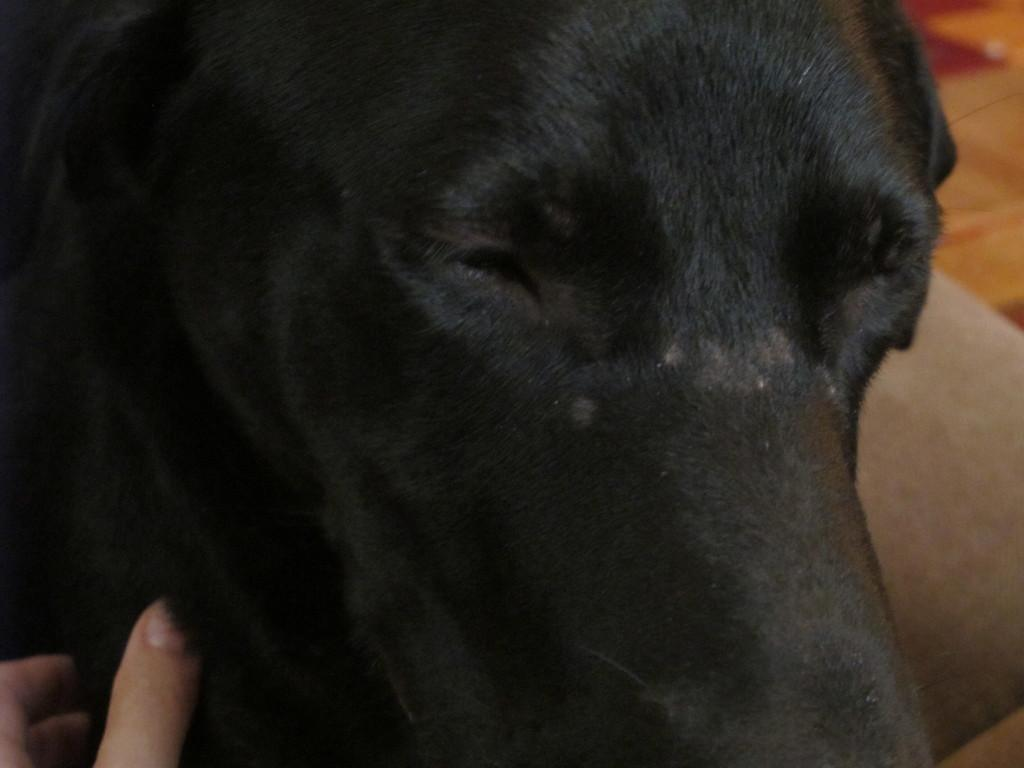What is the main subject in the center of the image? There is a dog in the center of the image. Can you describe the appearance of the dog? The dog is black in color. What else can be seen at the bottom side of the image? There are fingers at the bottom side of the image. What family members are depicted in the image? There are no family members depicted in the image; it only features a black dog and fingers. What type of war is being fought in the image? There is no war or conflict depicted in the image; it only features a black dog and fingers. 